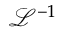Convert formula to latex. <formula><loc_0><loc_0><loc_500><loc_500>{ \mathcal { L } } ^ { - 1 }</formula> 